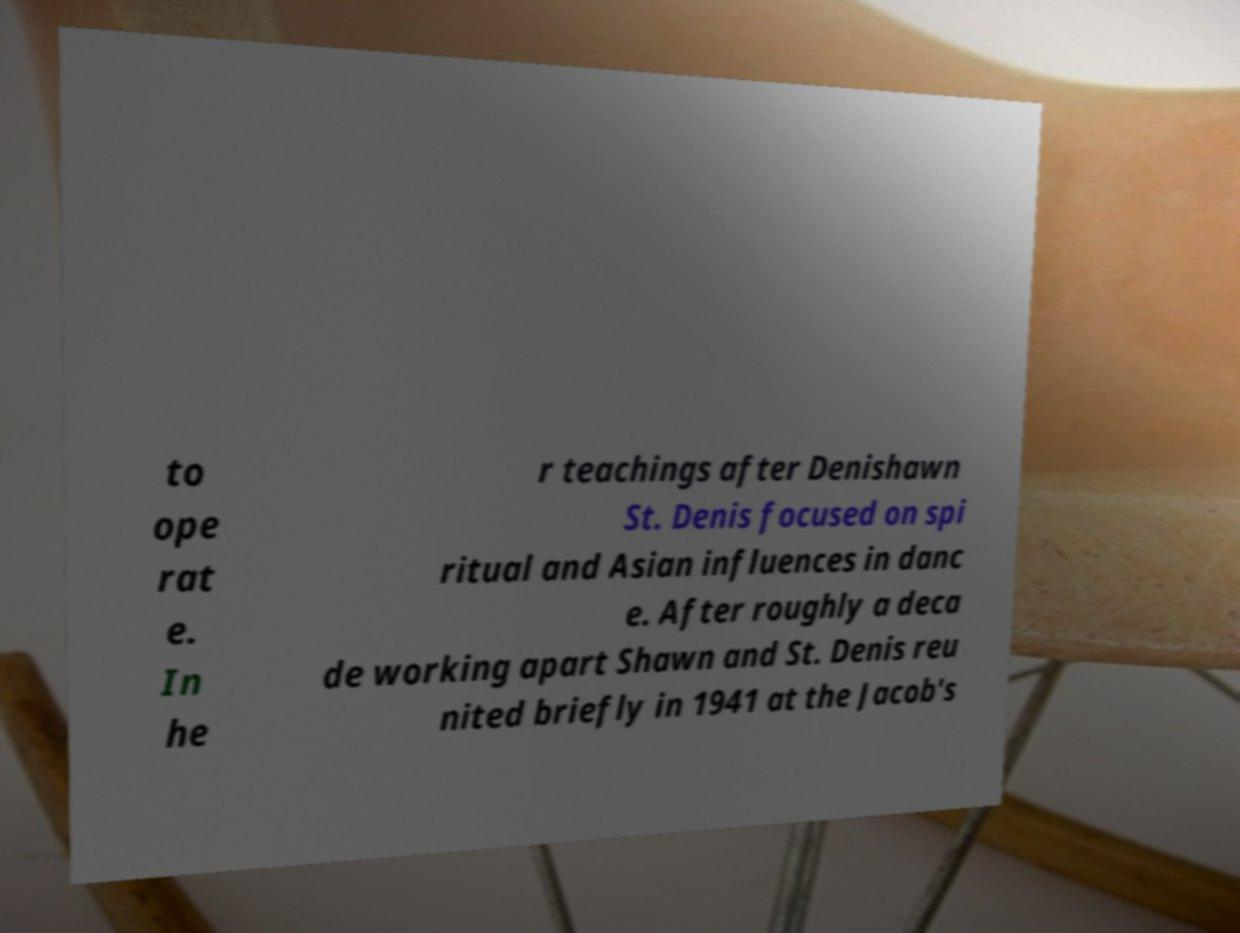For documentation purposes, I need the text within this image transcribed. Could you provide that? to ope rat e. In he r teachings after Denishawn St. Denis focused on spi ritual and Asian influences in danc e. After roughly a deca de working apart Shawn and St. Denis reu nited briefly in 1941 at the Jacob's 